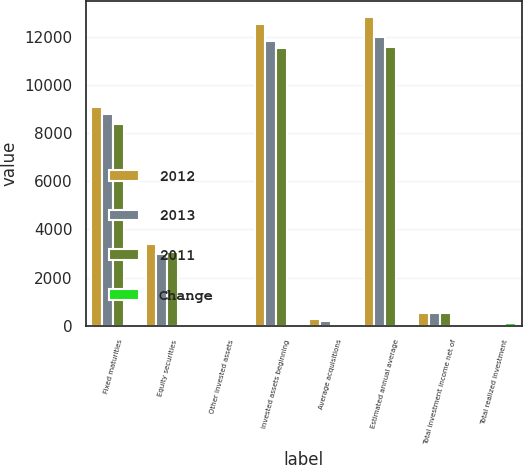<chart> <loc_0><loc_0><loc_500><loc_500><stacked_bar_chart><ecel><fcel>Fixed maturities<fcel>Equity securities<fcel>Other invested assets<fcel>Invested assets beginning<fcel>Average acquisitions<fcel>Estimated annual average<fcel>Total investment income net of<fcel>Total realized investment<nl><fcel>2012<fcel>9093<fcel>3373<fcel>68<fcel>12534<fcel>288<fcel>12822<fcel>529<fcel>83<nl><fcel>2013<fcel>8779<fcel>2956<fcel>66<fcel>11801<fcel>187<fcel>11988<fcel>531<fcel>42<nl><fcel>2011<fcel>8383<fcel>3041<fcel>84<fcel>11508<fcel>64<fcel>11572<fcel>525<fcel>70<nl><fcel>Change<fcel>4<fcel>14<fcel>3<fcel>6<fcel>54<fcel>7<fcel>0<fcel>98<nl></chart> 